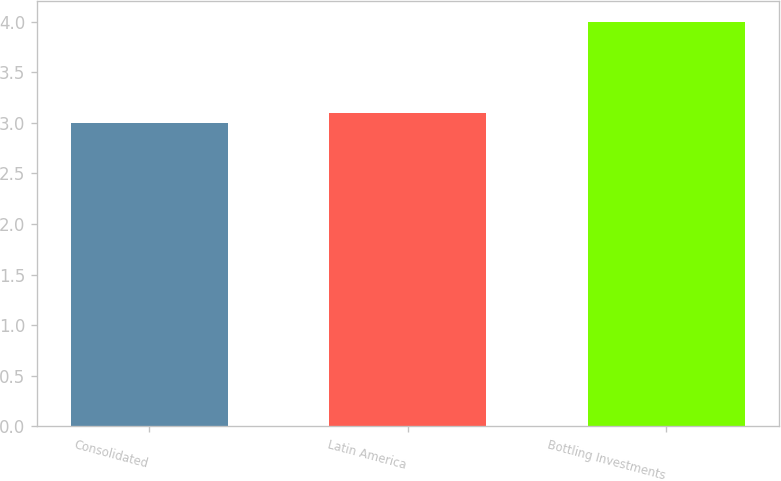<chart> <loc_0><loc_0><loc_500><loc_500><bar_chart><fcel>Consolidated<fcel>Latin America<fcel>Bottling Investments<nl><fcel>3<fcel>3.1<fcel>4<nl></chart> 